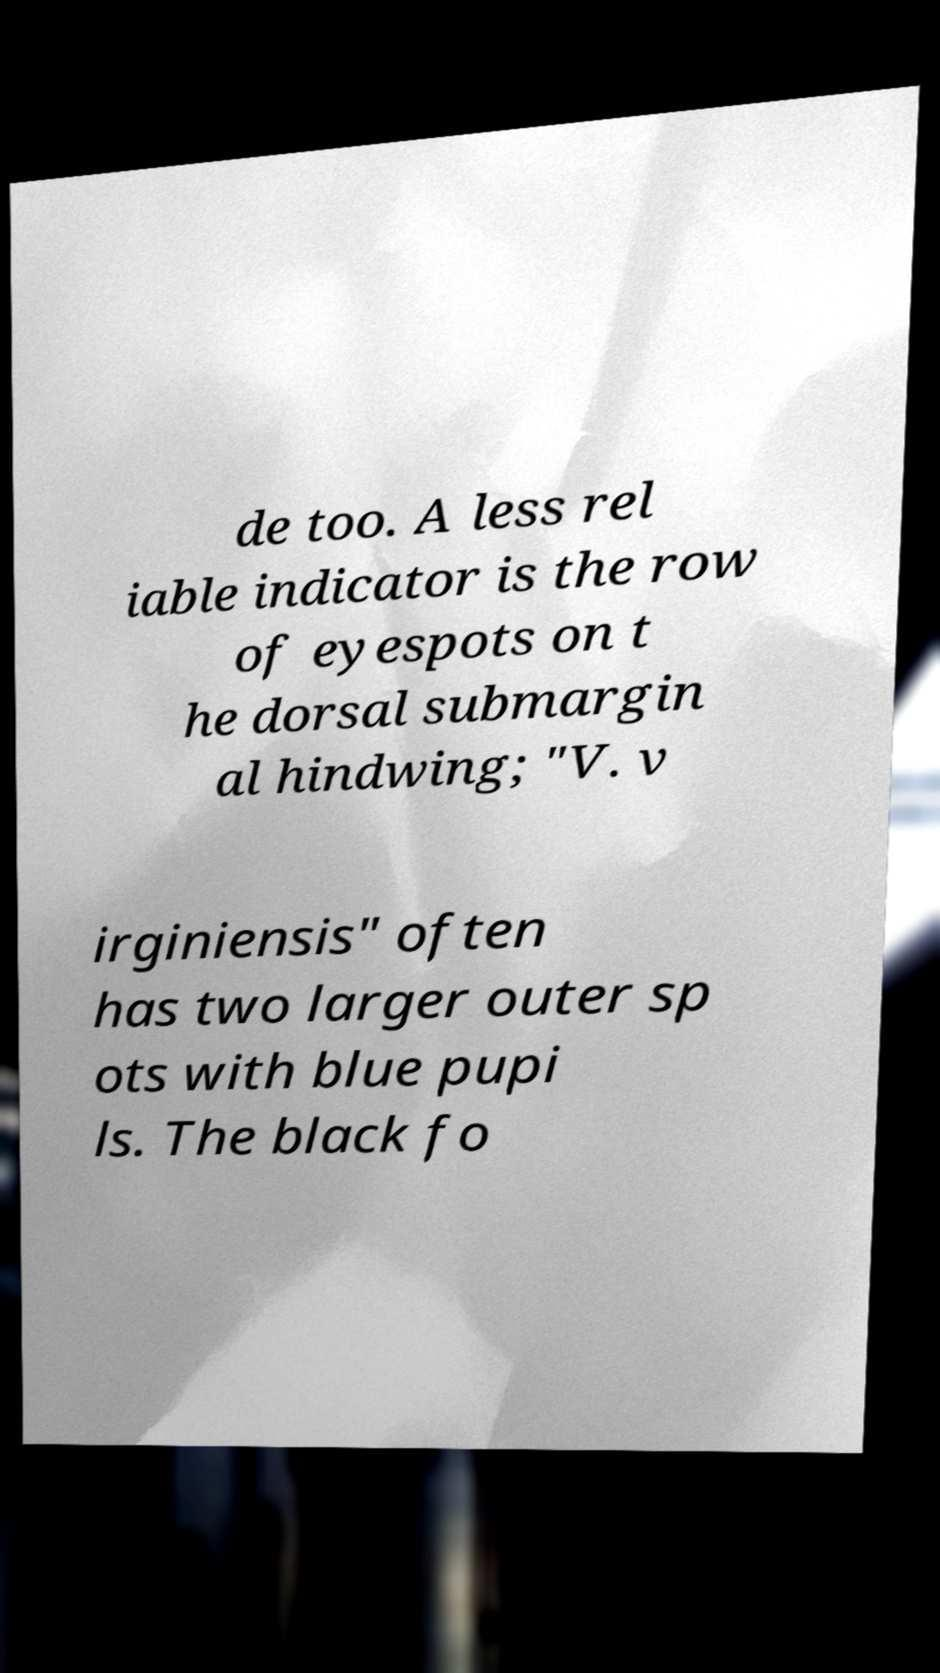What messages or text are displayed in this image? I need them in a readable, typed format. de too. A less rel iable indicator is the row of eyespots on t he dorsal submargin al hindwing; "V. v irginiensis" often has two larger outer sp ots with blue pupi ls. The black fo 